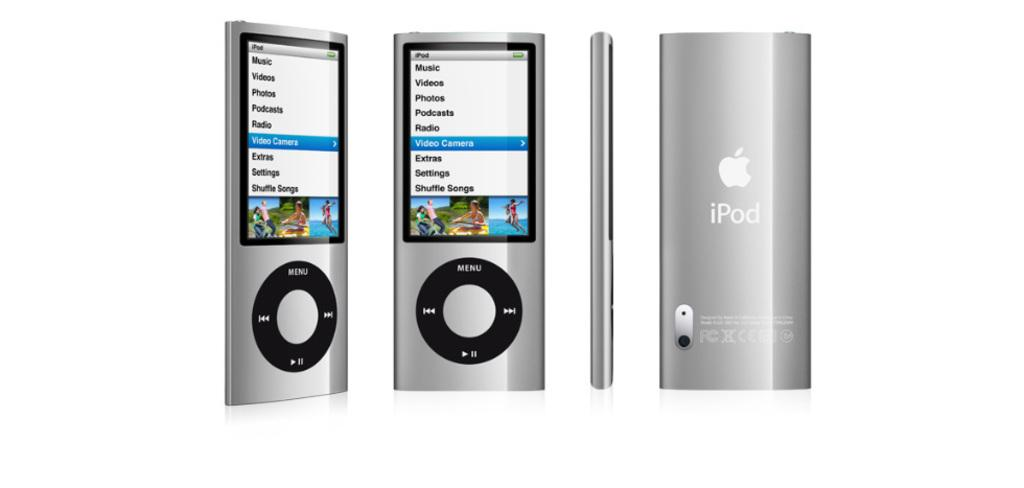Provide a one-sentence caption for the provided image. A silver iPod shows a menu with "music" as the top option. 